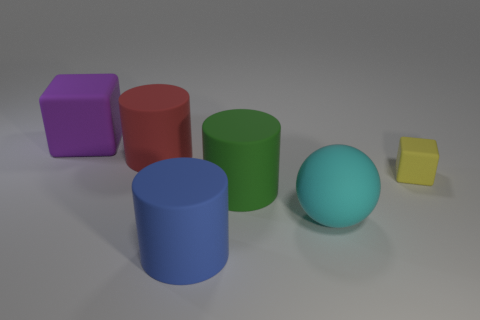Add 3 small yellow matte blocks. How many objects exist? 9 Subtract all blocks. How many objects are left? 4 Add 5 big blue rubber cylinders. How many big blue rubber cylinders are left? 6 Add 2 cylinders. How many cylinders exist? 5 Subtract 0 cyan cylinders. How many objects are left? 6 Subtract all big red spheres. Subtract all purple objects. How many objects are left? 5 